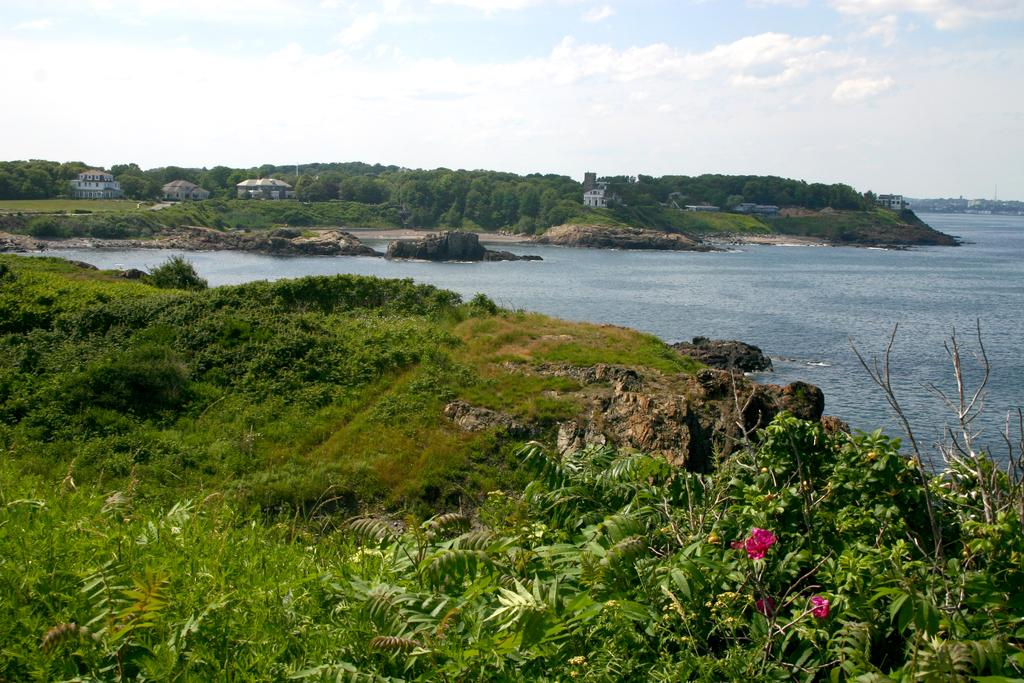What type of structures can be seen in the image? There are buildings in the image. What natural elements are present in the image? There are trees and water visible in the image. What type of flora can be seen in the image? Pink color flowers and plants are present in the image. What can be seen in the sky in the image? The sky is visible in the image, with a combination of white and blue colors. What type of appliance is being used to dry the sheet in the image? There is no appliance or sheet present in the image. What emotion is being expressed by the flowers in the image? The flowers do not express emotions; they are inanimate objects. 